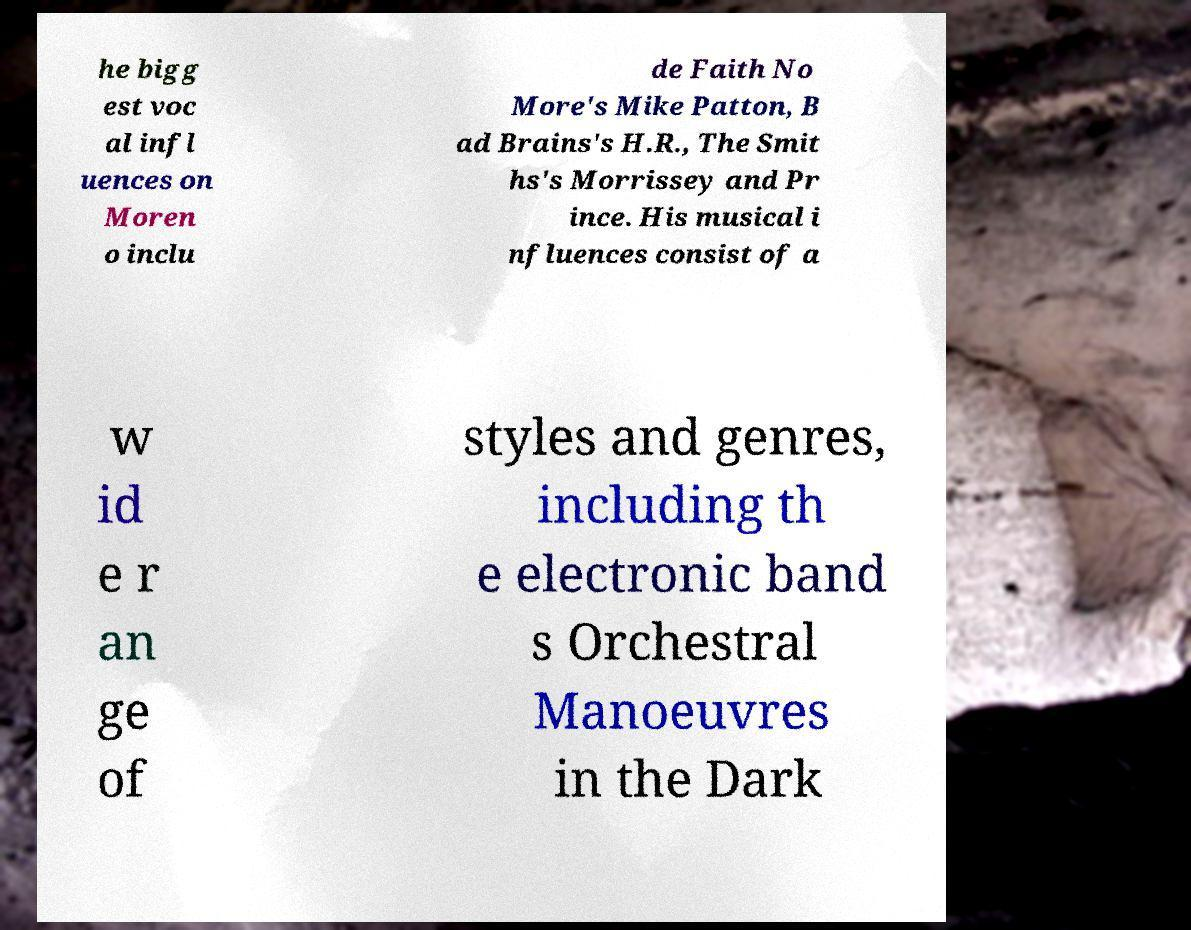Could you assist in decoding the text presented in this image and type it out clearly? he bigg est voc al infl uences on Moren o inclu de Faith No More's Mike Patton, B ad Brains's H.R., The Smit hs's Morrissey and Pr ince. His musical i nfluences consist of a w id e r an ge of styles and genres, including th e electronic band s Orchestral Manoeuvres in the Dark 